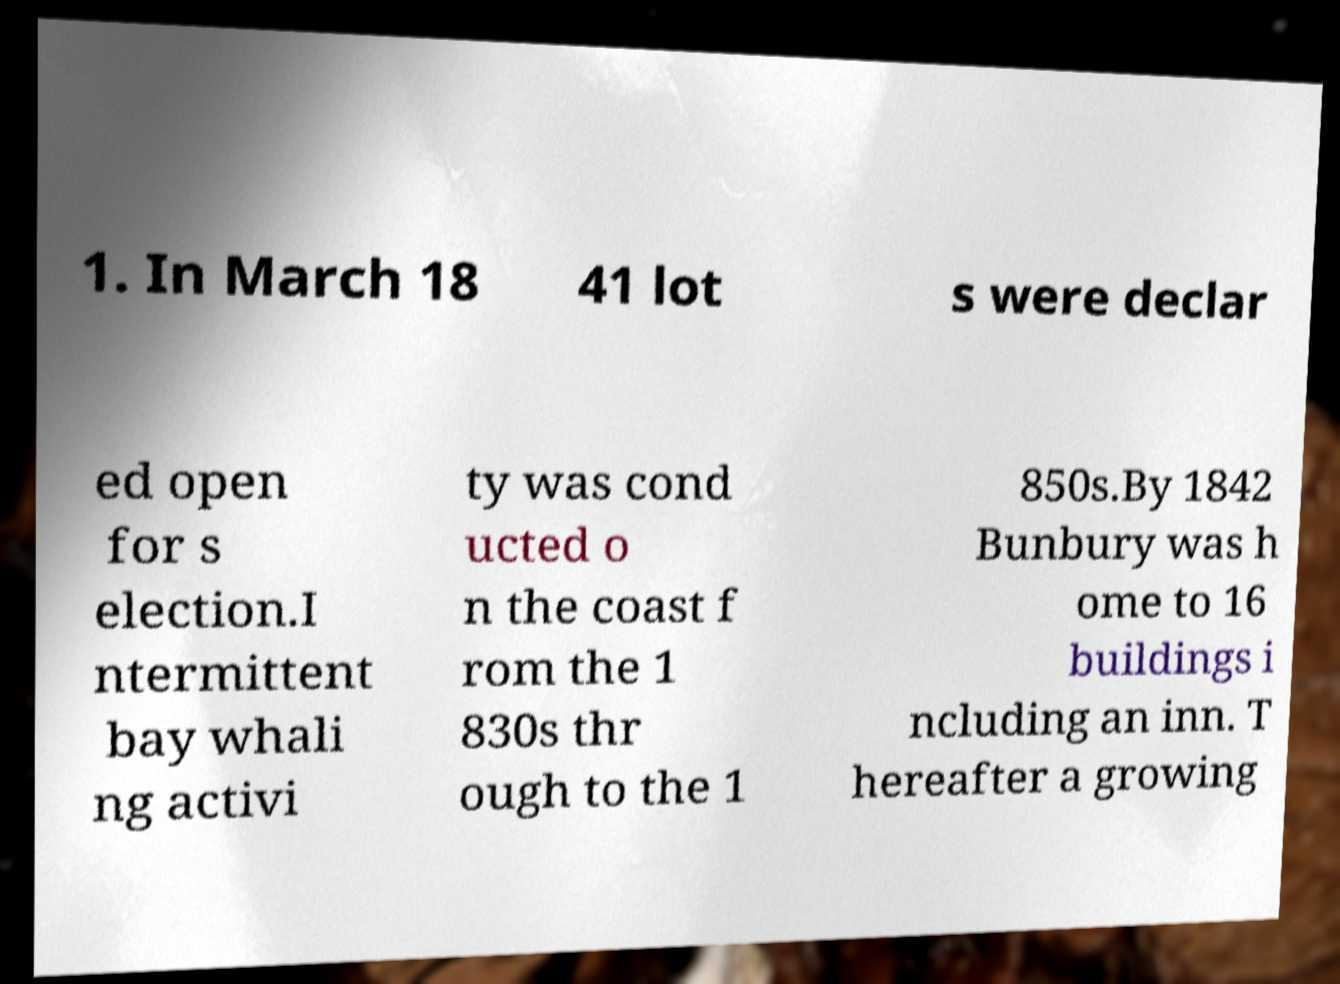There's text embedded in this image that I need extracted. Can you transcribe it verbatim? 1. In March 18 41 lot s were declar ed open for s election.I ntermittent bay whali ng activi ty was cond ucted o n the coast f rom the 1 830s thr ough to the 1 850s.By 1842 Bunbury was h ome to 16 buildings i ncluding an inn. T hereafter a growing 